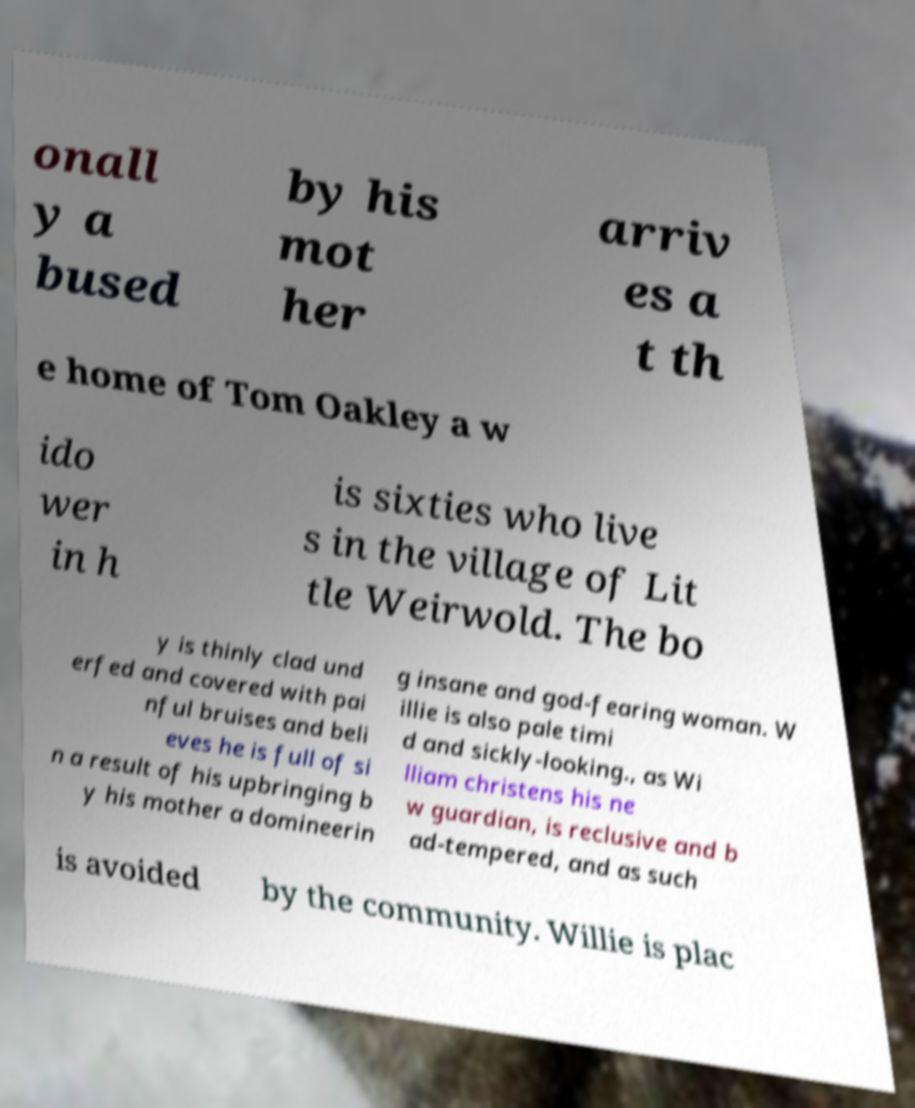For documentation purposes, I need the text within this image transcribed. Could you provide that? onall y a bused by his mot her arriv es a t th e home of Tom Oakley a w ido wer in h is sixties who live s in the village of Lit tle Weirwold. The bo y is thinly clad und erfed and covered with pai nful bruises and beli eves he is full of si n a result of his upbringing b y his mother a domineerin g insane and god-fearing woman. W illie is also pale timi d and sickly-looking., as Wi lliam christens his ne w guardian, is reclusive and b ad-tempered, and as such is avoided by the community. Willie is plac 